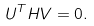Convert formula to latex. <formula><loc_0><loc_0><loc_500><loc_500>U ^ { T } H V = 0 .</formula> 